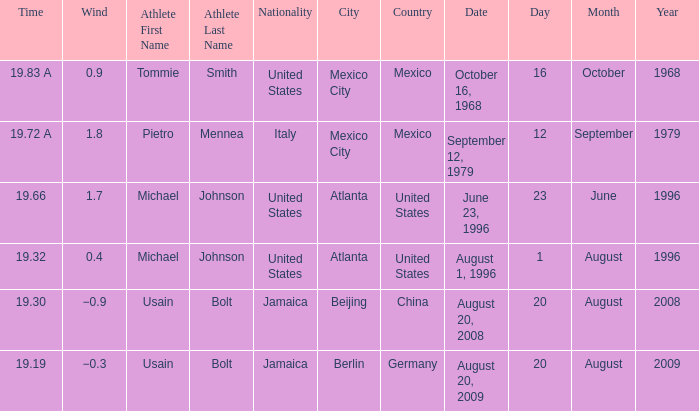Who was the athlete with a wind of 1.8? Pietro Mennea. 